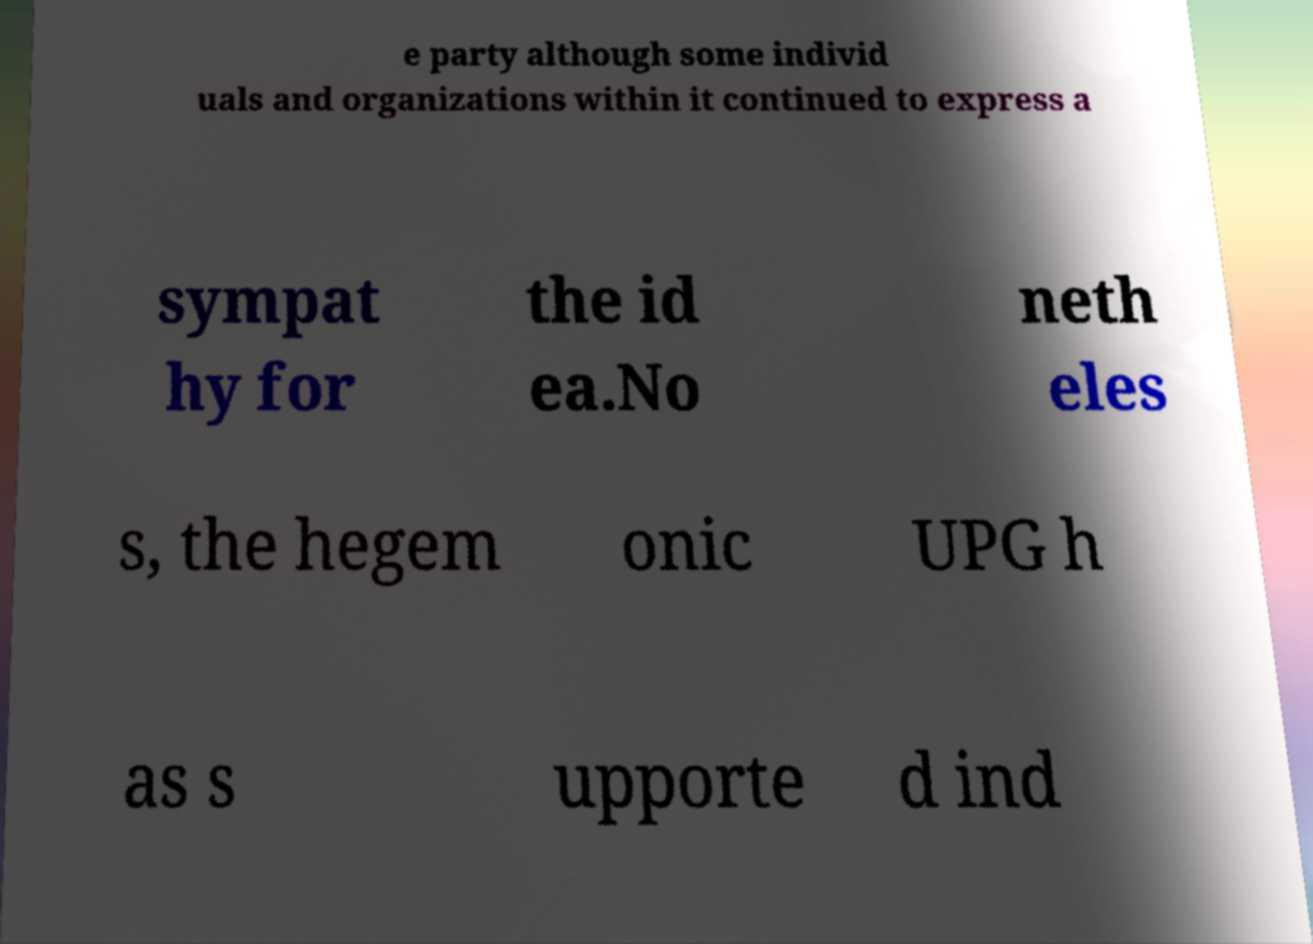Could you extract and type out the text from this image? e party although some individ uals and organizations within it continued to express a sympat hy for the id ea.No neth eles s, the hegem onic UPG h as s upporte d ind 